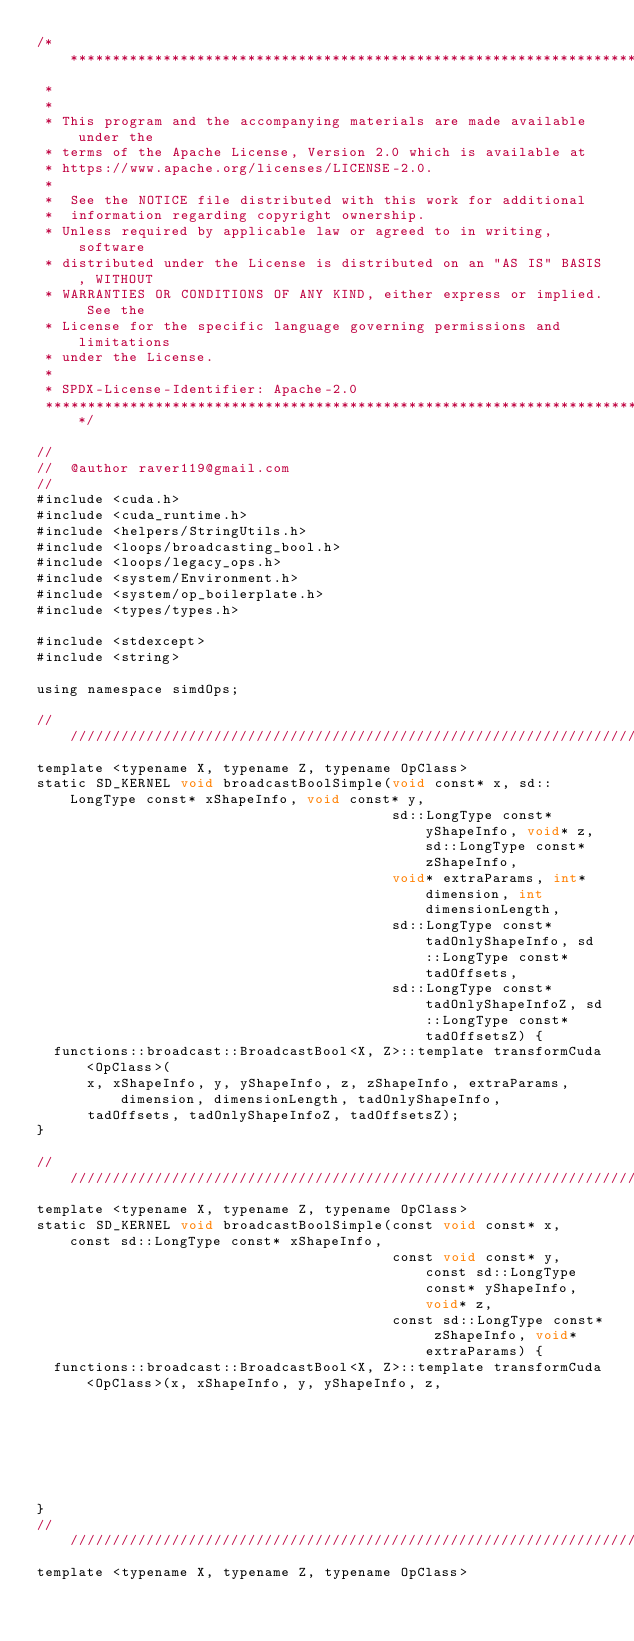Convert code to text. <code><loc_0><loc_0><loc_500><loc_500><_Cuda_>/* ******************************************************************************
 *
 *
 * This program and the accompanying materials are made available under the
 * terms of the Apache License, Version 2.0 which is available at
 * https://www.apache.org/licenses/LICENSE-2.0.
 *
 *  See the NOTICE file distributed with this work for additional
 *  information regarding copyright ownership.
 * Unless required by applicable law or agreed to in writing, software
 * distributed under the License is distributed on an "AS IS" BASIS, WITHOUT
 * WARRANTIES OR CONDITIONS OF ANY KIND, either express or implied. See the
 * License for the specific language governing permissions and limitations
 * under the License.
 *
 * SPDX-License-Identifier: Apache-2.0
 ******************************************************************************/

//
//  @author raver119@gmail.com
//
#include <cuda.h>
#include <cuda_runtime.h>
#include <helpers/StringUtils.h>
#include <loops/broadcasting_bool.h>
#include <loops/legacy_ops.h>
#include <system/Environment.h>
#include <system/op_boilerplate.h>
#include <types/types.h>

#include <stdexcept>
#include <string>

using namespace simdOps;

//////////////////////////////////////////////////////////////////////////
template <typename X, typename Z, typename OpClass>
static SD_KERNEL void broadcastBoolSimple(void const* x, sd::LongType const* xShapeInfo, void const* y,
                                          sd::LongType const* yShapeInfo, void* z, sd::LongType const* zShapeInfo,
                                          void* extraParams, int* dimension, int dimensionLength,
                                          sd::LongType const* tadOnlyShapeInfo, sd::LongType const* tadOffsets,
                                          sd::LongType const* tadOnlyShapeInfoZ, sd::LongType const* tadOffsetsZ) {
  functions::broadcast::BroadcastBool<X, Z>::template transformCuda<OpClass>(
      x, xShapeInfo, y, yShapeInfo, z, zShapeInfo, extraParams, dimension, dimensionLength, tadOnlyShapeInfo,
      tadOffsets, tadOnlyShapeInfoZ, tadOffsetsZ);
}

//////////////////////////////////////////////////////////////////////////
template <typename X, typename Z, typename OpClass>
static SD_KERNEL void broadcastBoolSimple(const void const* x, const sd::LongType const* xShapeInfo,
                                          const void const* y, const sd::LongType const* yShapeInfo, void* z,
                                          const sd::LongType const* zShapeInfo, void* extraParams) {
  functions::broadcast::BroadcastBool<X, Z>::template transformCuda<OpClass>(x, xShapeInfo, y, yShapeInfo, z,
                                                                             zShapeInfo, extraParams);
}
//////////////////////////////////////////////////////////////////////////
template <typename X, typename Z, typename OpClass></code> 